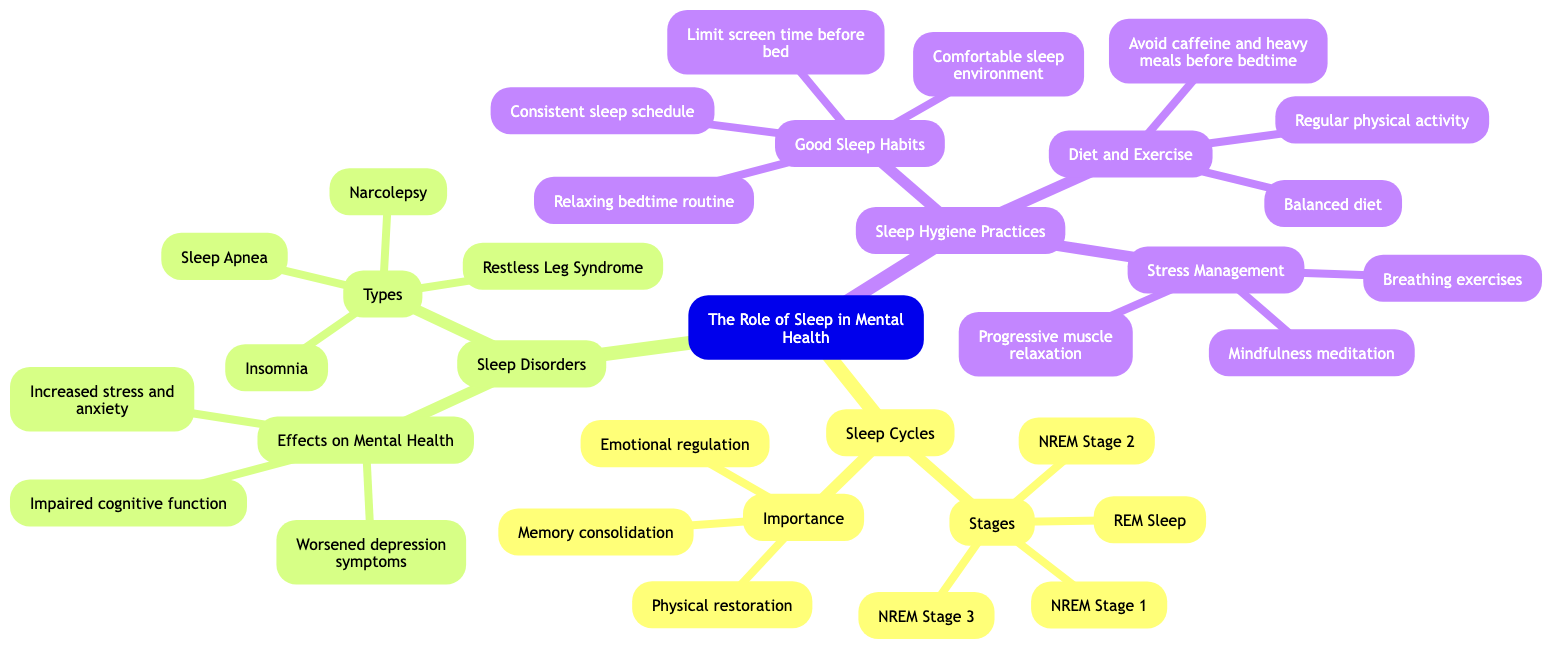What are the four stages of sleep? The diagram lists four stages under the "Stages" node in "Sleep Cycles": NREM Stage 1, NREM Stage 2, NREM Stage 3, and REM Sleep.
Answer: NREM Stage 1, NREM Stage 2, NREM Stage 3, REM Sleep How many types of sleep disorders are mentioned? In the "Types" section under "Sleep Disorders", there are four types listed: Insomnia, Sleep Apnea, Restless Leg Syndrome, and Narcolepsy. Thus, the total number is counted as four.
Answer: 4 What is one effect of sleep disorders on mental health? In the "Effects on Mental Health" section under "Sleep Disorders," one of the listed effects is "Increased stress and anxiety." This is clearly stated in the diagram.
Answer: Increased stress and anxiety Name two good sleep habits mentioned. The "Good Sleep Habits" section under "Sleep Hygiene Practices" outlines four habits, among which two are "Consistent sleep schedule" and "Relaxing bedtime routine." These can be chosen from the options provided in the diagram.
Answer: Consistent sleep schedule, Relaxing bedtime routine What practice is recommended for stress management? The "Stress Management" section under "Sleep Hygiene Practices" includes three practices, one of which is "Mindfulness meditation." This can be confirmed by examining that specific node in the diagram.
Answer: Mindfulness meditation How do sleep cycles contribute to emotional regulation? The "Importance" section under "Sleep Cycles" lists "Emotional regulation" as one of the key functions. This indicates that emotional regulation is directly connected to the role of sleep cycles according to the diagram.
Answer: Emotional regulation Which sleep disorder is characterized by difficulty falling asleep? "Insomnia" is specifically mentioned in the "Types" section under "Sleep Disorders" as the condition characterized by difficulty in initiating or maintaining sleep. This specific connection is noted in the diagram.
Answer: Insomnia What are two diet-related sleep hygiene practices? The "Diet and Exercise" section under "Sleep Hygiene Practices" lists three practices, of which "Balanced diet" and "Avoid caffeine and heavy meals before bedtime" can be selected as diet-related recommendations. These are explicitly indicated in the diagram.
Answer: Balanced diet, Avoid caffeine and heavy meals before bedtime How many importance aspects of sleep cycles are there? The diagram shows that under the "Importance" section in "Sleep Cycles," there are three aspects: "Memory consolidation," "Emotional regulation," and "Physical restoration." Thus, adding these up results in three importance aspects.
Answer: 3 